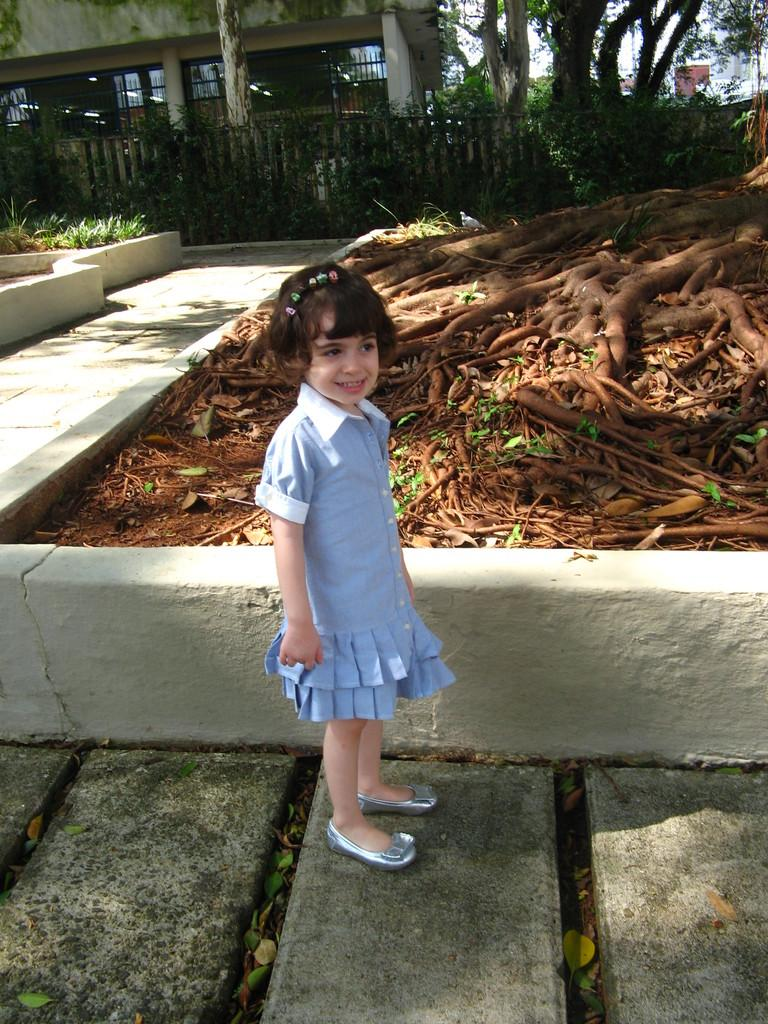What is the main subject of the image? There is a girl standing in the image. What can be seen at the girl's feet in the image? Tree roots are visible in the image. What type of vegetation is present in the image? Grass is present in the image. What architectural features can be seen in the background of the image? There is a fence, trees, a wall, and the sky visible in the background of the image. What position does the girl's aunt hold in the image? There is no mention of an aunt in the image, so it is not possible to determine her position. What type of street can be seen in the image? There is no street visible in the image; it features a girl standing with tree roots, grass, and architectural features in the background. 